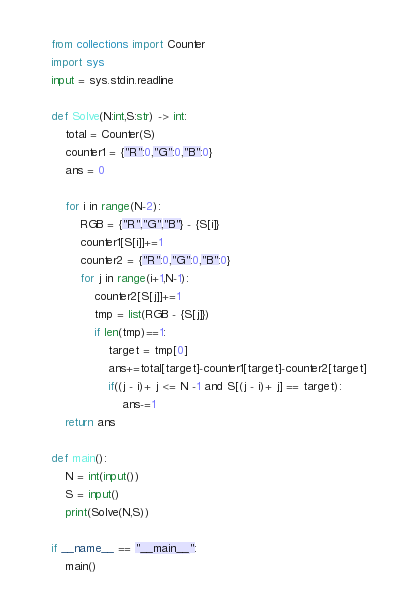Convert code to text. <code><loc_0><loc_0><loc_500><loc_500><_Python_>from collections import Counter
import sys
input = sys.stdin.readline

def Solve(N:int,S:str) -> int:
    total = Counter(S)
    counter1 = {"R":0,"G":0,"B":0}
    ans = 0

    for i in range(N-2):
        RGB = {"R","G","B"} - {S[i]}
        counter1[S[i]]+=1
        counter2 = {"R":0,"G":0,"B":0}
        for j in range(i+1,N-1):
            counter2[S[j]]+=1
            tmp = list(RGB - {S[j]})
            if len(tmp)==1:
                target = tmp[0]
                ans+=total[target]-counter1[target]-counter2[target]
                if((j - i)+ j <= N -1 and S[(j - i)+ j] == target):
                    ans-=1
    return ans

def main():
    N = int(input())
    S = input()
    print(Solve(N,S))

if __name__ == "__main__":
    main()


</code> 